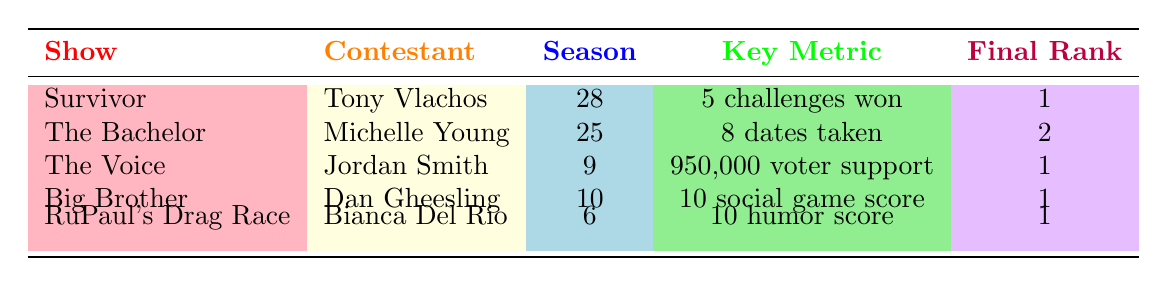What contestant in "Survivor" had the highest final rank? According to the table, Tony Vlachos had a final rank of 1 in "Survivor."
Answer: Tony Vlachos How many challenges did Bianca Del Rio win in "RuPaul's Drag Race"? The table states that Bianca Del Rio won 5 challenges.
Answer: 5 Did Michelle Young receive more roses than dates taken? The table shows that Michelle Young received 6 roses and took 8 dates, indicating she did not receive more roses.
Answer: No Which contestant had the highest social game score? Dan Gheesling had a social game score of 10, which is the highest in the table.
Answer: Dan Gheesling What is the total number of voter support received by Jordan Smith and Bianca Del Rio combined? Jordan Smith had 950,000 voter support and Bianca Del Rio had 240,000 fan votes. The total is 950,000 + 240,000 = 1,190,000.
Answer: 1,190,000 How many contestants in the table achieved a final rank of 1? By inspecting the table, the contestants with a final rank of 1 are: Tony Vlachos, Jordan Smith, Dan Gheesling, and Bianca Del Rio. This sums up to 4 contestants.
Answer: 4 What was the average number of challenges won by the contestants listed in the table? The contestants who won challenges are Tony Vlachos with 5 and Bianca Del Rio with 5. The average is (5 + 5) / 2 = 5.
Answer: 5 Which show had the contestant that faced the highest number of episodes? Michelle Young from "The Bachelor" featured in 10 episodes, which is the highest in the table.
Answer: The Bachelor Was there a contestant who had both a high drama score and an impressive final rank? Michelle Young had a drama score of 4 and a final rank of 2, which is relatively good though not the highest possible. Still, it's notable in its own right.
Answer: Yes 